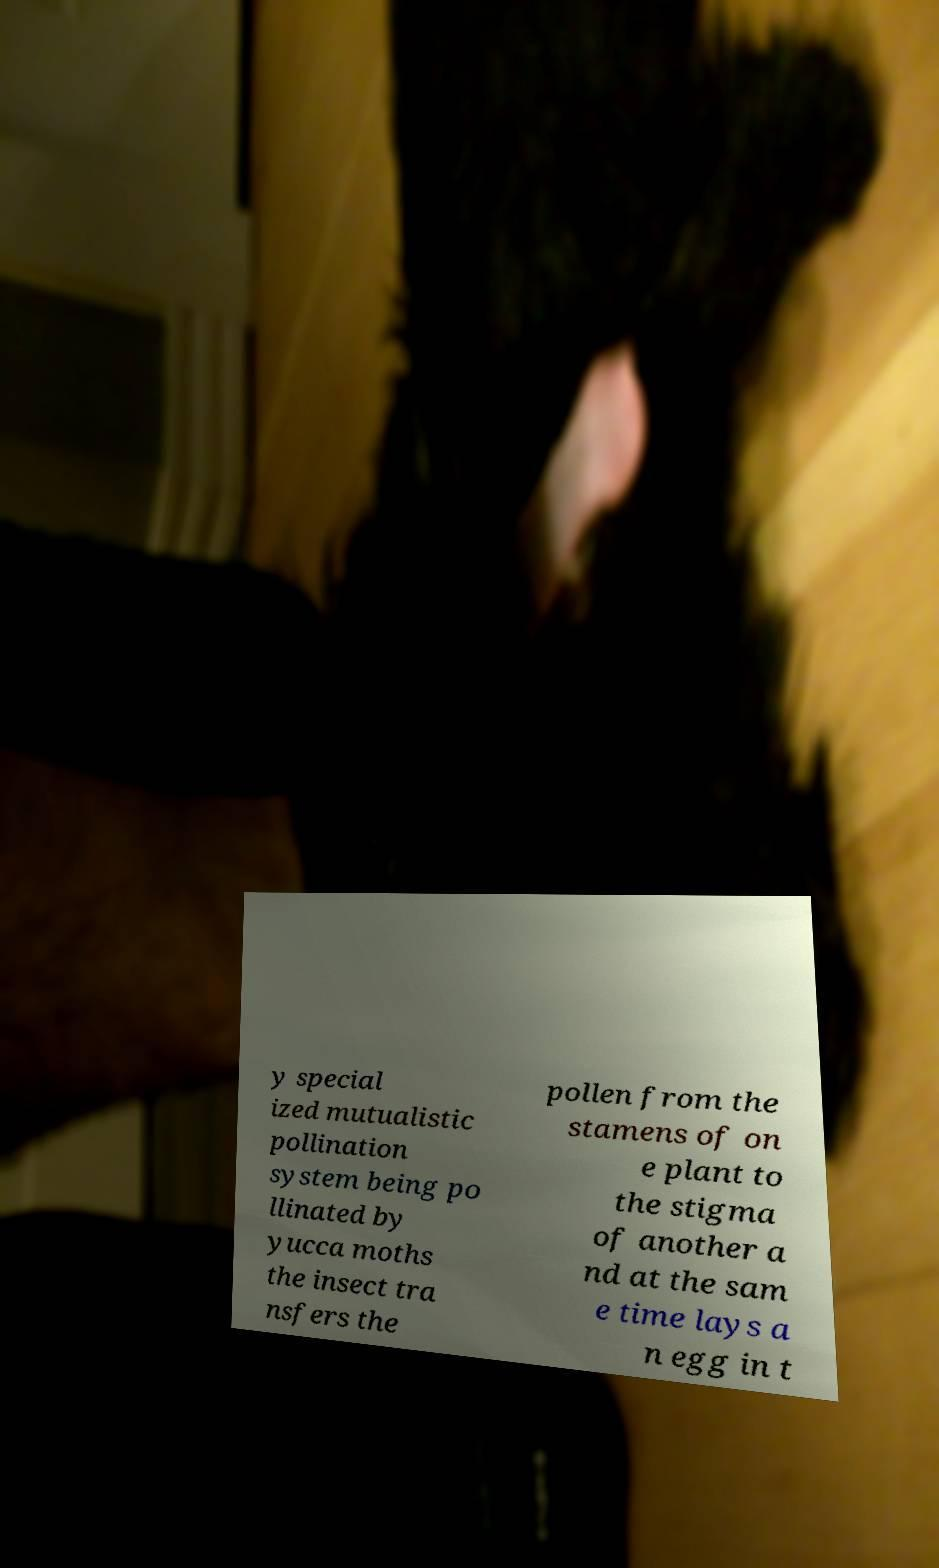For documentation purposes, I need the text within this image transcribed. Could you provide that? y special ized mutualistic pollination system being po llinated by yucca moths the insect tra nsfers the pollen from the stamens of on e plant to the stigma of another a nd at the sam e time lays a n egg in t 